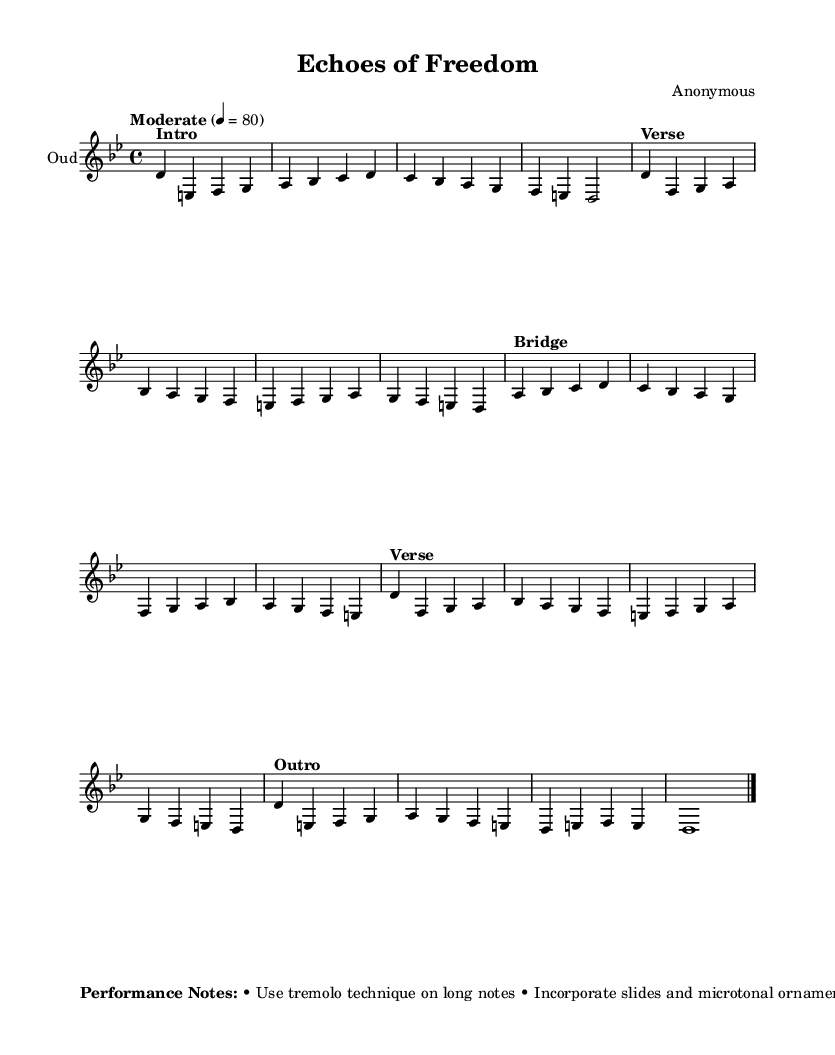What is the time signature of this music? The time signature is indicated at the beginning of the music, which shows there are four beats per measure. This is represented by the notation 4/4.
Answer: 4/4 What key is this piece composed in? The key signature appears at the start of the sheet music; the note D is indicated at the start, which corresponds to the key of D Phrygian, known for its minor tonality.
Answer: D Phrygian What is the tempo marking for this composition? The tempo is specified in the music with the term "Moderate" and a designation of 80 beats per minute, which suggests a calm pace for performance.
Answer: 80 Which performance technique is suggested for long notes? In the performance notes section, it advises using the tremolo technique on long notes, indicating a specific style of playing intended to enhance the expressive quality of those notes.
Answer: Tremolo How many sections are in the piece? By analyzing the structure of the music, it is divided into five clear sections: Intro, Verse, Bridge, Verse (repeat), and Outro; each has distinct characteristics and contributes to the overall composition.
Answer: Five What microtonal techniques are indicated for this music? The performance notes encourage the use of slides and microtonal ornaments between notes, which are essential features of Middle Eastern music and contribute to the cultural authenticity of the piece.
Answer: Slides and microtonal ornaments What is the overall theme of this composition? The title "Echoes of Freedom" and the performance notes that suggest a growing intensity reflect social movements and justice, indicating the theme is aimed at inspiring thoughts about freedom and social justice.
Answer: Social justice 